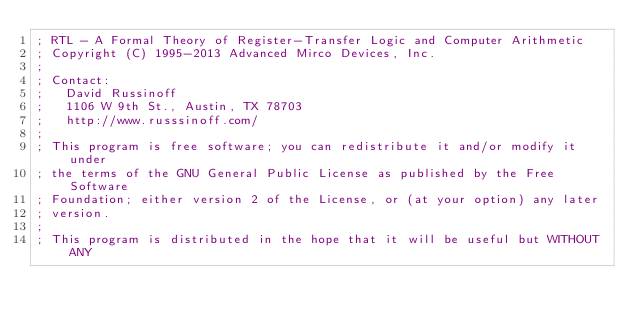<code> <loc_0><loc_0><loc_500><loc_500><_Lisp_>; RTL - A Formal Theory of Register-Transfer Logic and Computer Arithmetic 
; Copyright (C) 1995-2013 Advanced Mirco Devices, Inc. 
;
; Contact:
;   David Russinoff
;   1106 W 9th St., Austin, TX 78703
;   http://www.russsinoff.com/
;
; This program is free software; you can redistribute it and/or modify it under
; the terms of the GNU General Public License as published by the Free Software
; Foundation; either version 2 of the License, or (at your option) any later
; version.
;
; This program is distributed in the hope that it will be useful but WITHOUT ANY</code> 